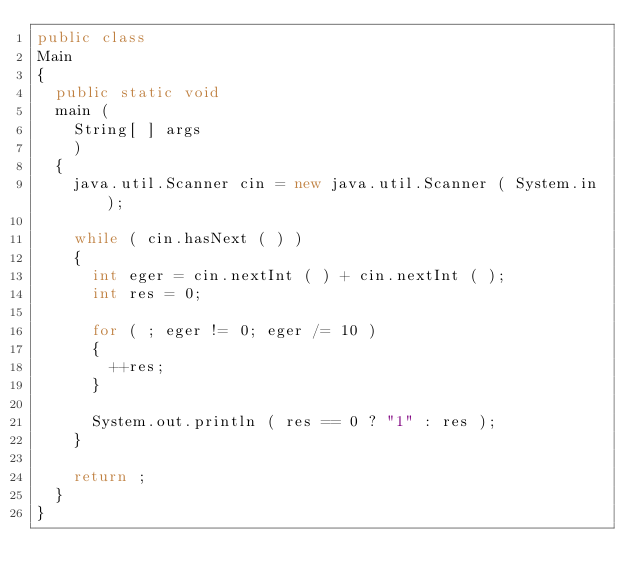<code> <loc_0><loc_0><loc_500><loc_500><_Java_>public class
Main
{
  public static void
  main (
    String[ ] args
    )
  {
    java.util.Scanner cin = new java.util.Scanner ( System.in );

    while ( cin.hasNext ( ) )
    {
      int eger = cin.nextInt ( ) + cin.nextInt ( );
      int res = 0;

      for ( ; eger != 0; eger /= 10 )
      {
        ++res;
      }

      System.out.println ( res == 0 ? "1" : res );
    }

    return ;
  }
}</code> 